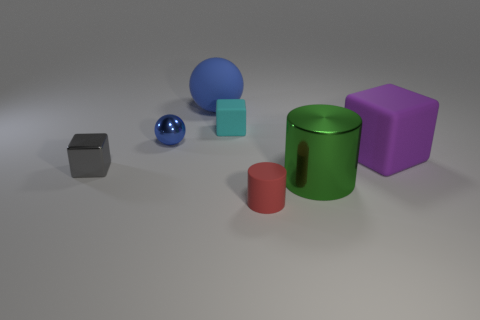What is the size of the purple thing that is the same shape as the small gray metallic object?
Offer a very short reply. Large. Are the tiny red cylinder that is in front of the small cyan cube and the small object on the left side of the small metallic ball made of the same material?
Your answer should be compact. No. How many metal things are big yellow cylinders or large balls?
Your answer should be compact. 0. There is a small thing that is right of the tiny cube on the right side of the big rubber thing that is behind the cyan block; what is its material?
Provide a succinct answer. Rubber. Does the metal object that is right of the small blue shiny object have the same shape as the small thing that is to the right of the cyan object?
Provide a succinct answer. Yes. There is a object that is left of the blue sphere that is in front of the blue rubber thing; what color is it?
Make the answer very short. Gray. What number of spheres are small gray metal things or shiny things?
Your response must be concise. 1. What number of tiny metal things are to the left of the blue thing that is in front of the blue matte thing that is behind the large purple cube?
Your answer should be compact. 1. There is a matte thing that is the same color as the tiny metal sphere; what is its size?
Offer a terse response. Large. Are there any big green things made of the same material as the purple thing?
Your answer should be very brief. No. 